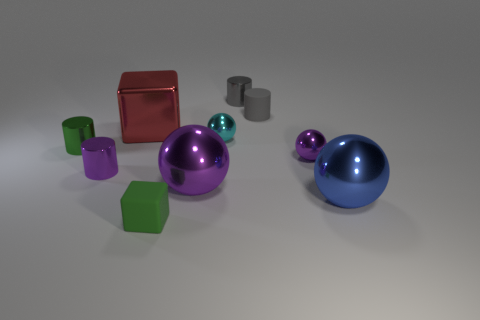Are there fewer blue shiny things than yellow shiny balls?
Keep it short and to the point. No. Are there any purple metal objects of the same size as the green rubber object?
Keep it short and to the point. Yes. There is a cyan thing; does it have the same shape as the tiny purple object right of the large purple thing?
Ensure brevity in your answer.  Yes. How many cylinders are large blue metal things or tiny green objects?
Make the answer very short. 1. The small block has what color?
Your response must be concise. Green. Are there more large metallic things than tiny purple spheres?
Give a very brief answer. Yes. How many things are either large objects that are to the right of the small block or cylinders?
Your response must be concise. 6. Does the tiny purple ball have the same material as the small block?
Make the answer very short. No. There is a green object that is the same shape as the red object; what size is it?
Offer a terse response. Small. Is the shape of the rubber thing in front of the big red shiny object the same as the big object that is left of the small cube?
Ensure brevity in your answer.  Yes. 